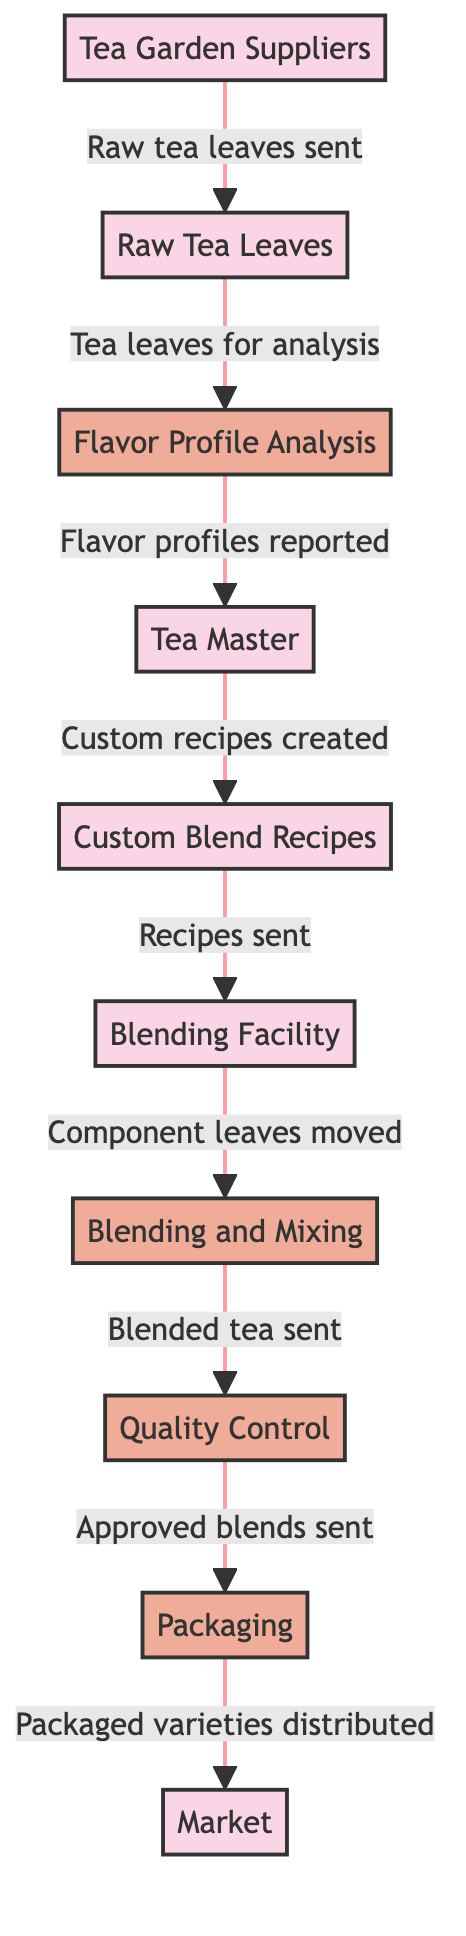What entity supplies raw tea leaves? The diagram shows "Tea Garden Suppliers" as the source entity that sends raw tea leaves to the process.
Answer: Tea Garden Suppliers How many processes are involved in the workflow? By counting the elements labeled as processes in the diagram, there are four: Flavor Profile Analysis, Blending and Mixing, Quality Control, and Packaging.
Answer: Four What does the Tea Master do with the flavor profiles? According to the flow, the Tea Master receives the flavor profiles and creates custom blend recipes based on them.
Answer: Custom blend recipes What is the final step before tea is distributed to the market? The diagram indicates that the Packaging process occurs right before the packaged tea varieties are sent to the market.
Answer: Packaging How do raw tea leaves move through the system? Raw tea leaves are sent from the Tea Garden Suppliers to the Flavor Profile Analysis, then to the Tea Master, and further downstream to Custom Blend Recipes and Blending Facility. This involves multiple flow transitions.
Answer: Flavor Profile Analysis, Tea Master, Custom Blend Recipes, Blending Facility Which entity sends approved blends to Packaging? In the diagram, the Quality Control process is shown to send approved blends to the next step, which is Packaging.
Answer: Quality Control What is the relationship between Blending Facility and Blending and Mixing? The diagram depicts that the Blending Facility sends component leaves to the Blending and Mixing process, indicating a direct flow from one to another.
Answer: Component leaves moved What type of analysis occurs after the raw tea leaves are received? The diagram clearly indicates that the raw tea leaves undergo "Flavor Profile Analysis" after they are received from the suppliers.
Answer: Flavor Profile Analysis Which element receives recipes from the Tea Master? Custom Blend Recipes is the entity that receives the recipes created by the Tea Master, as indicated by the flow.
Answer: Custom Blend Recipes 